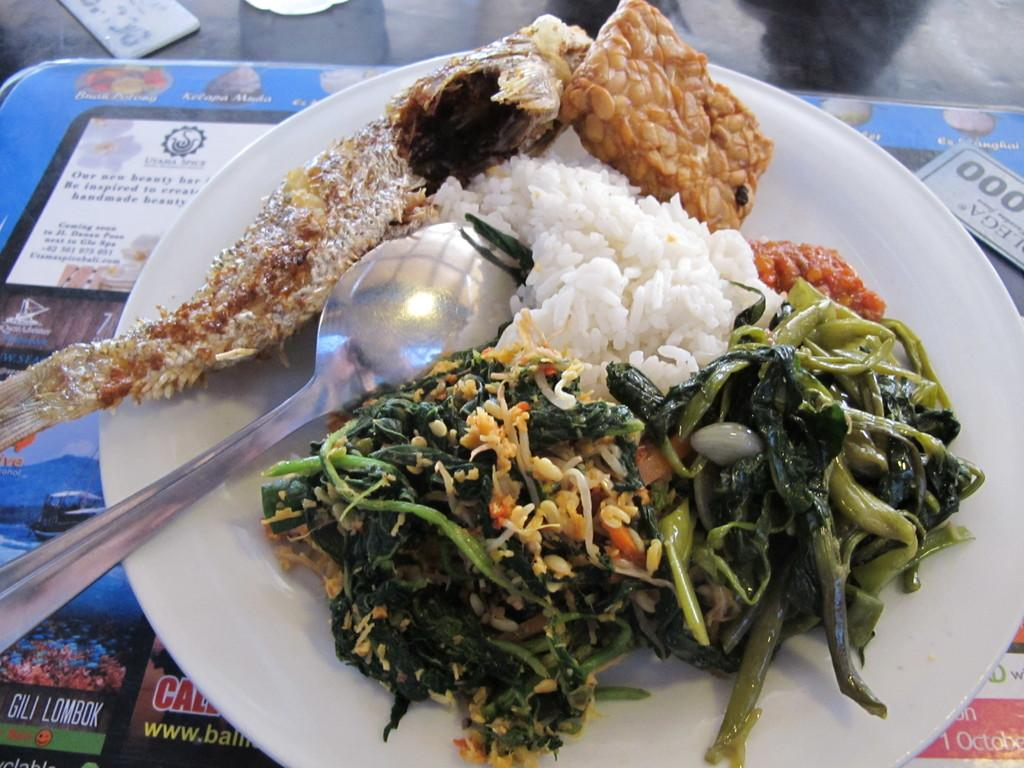What is on the table in the image? There is a plate on the table. What is on the plate? There is rice and curries on the plate. What utensil is placed on the plate? There is a spoon on the plate. What type of war is depicted in the image? There is no war depicted in the image; it features a plate with rice and curries, along with a spoon. 